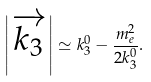Convert formula to latex. <formula><loc_0><loc_0><loc_500><loc_500>\left | \overrightarrow { k _ { 3 } } \right | \simeq k _ { 3 } ^ { 0 } - \frac { m _ { e } ^ { 2 } } { 2 k _ { 3 } ^ { 0 } } .</formula> 